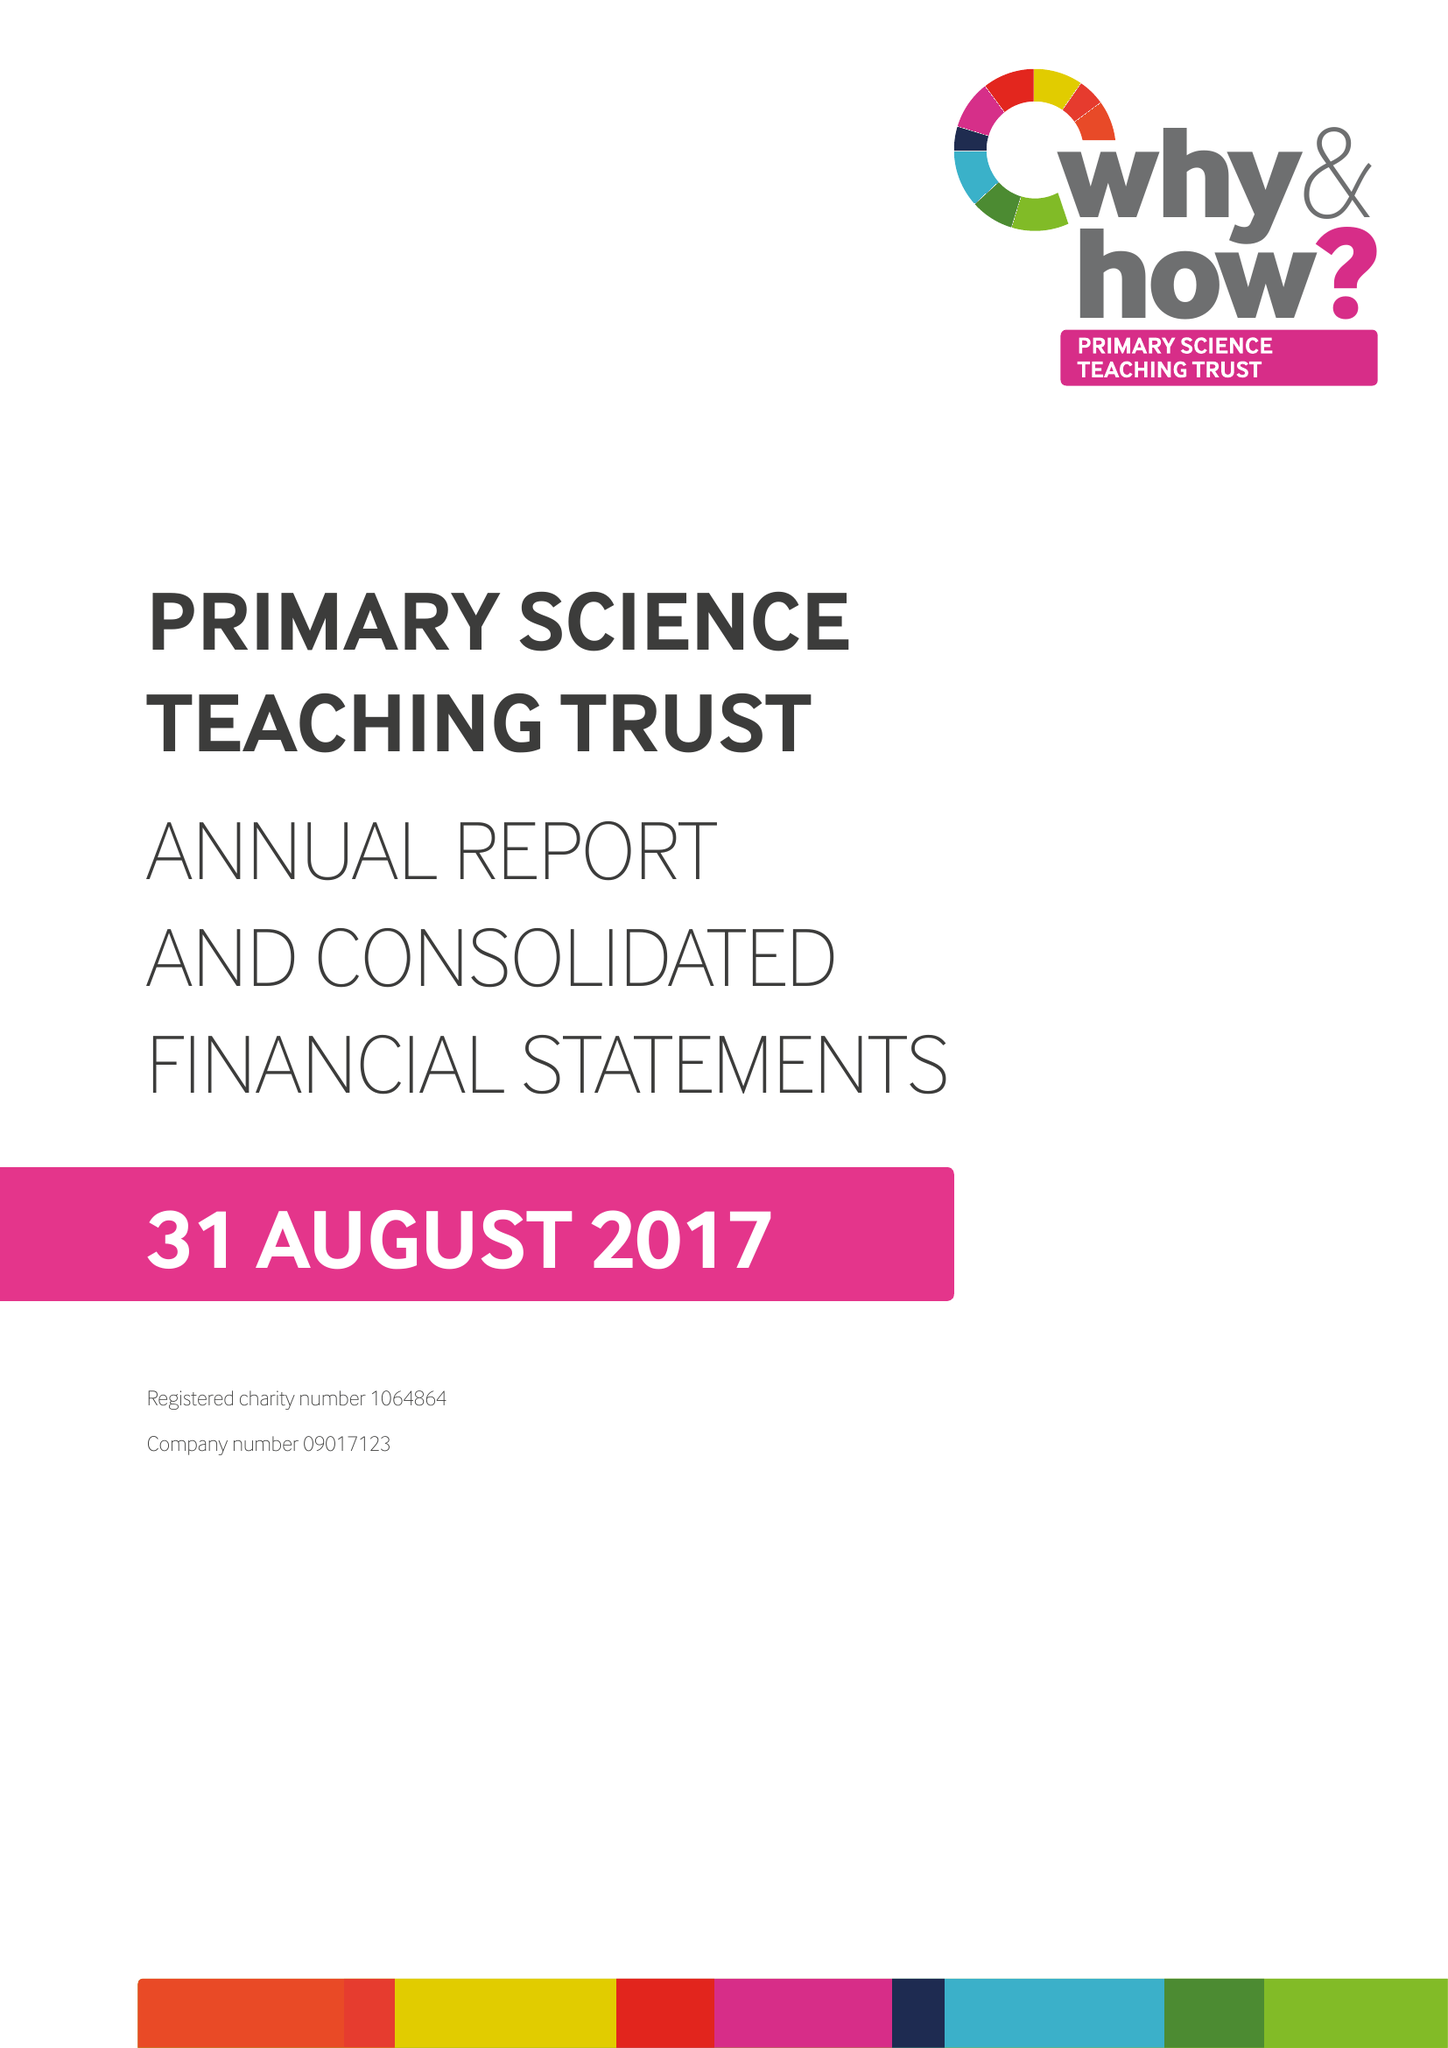What is the value for the charity_name?
Answer the question using a single word or phrase. Primary Science Teaching Trust 